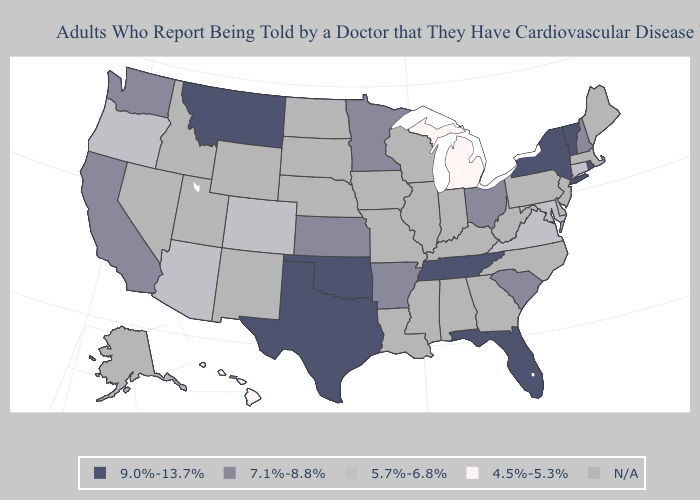What is the lowest value in the USA?
Concise answer only. 4.5%-5.3%. Name the states that have a value in the range 7.1%-8.8%?
Short answer required. Arkansas, California, Kansas, Minnesota, New Hampshire, Ohio, South Carolina, Washington. Does Ohio have the lowest value in the MidWest?
Be succinct. No. What is the value of Nebraska?
Answer briefly. N/A. Name the states that have a value in the range 9.0%-13.7%?
Give a very brief answer. Florida, Montana, New York, Oklahoma, Rhode Island, Tennessee, Texas, Vermont. What is the value of Indiana?
Give a very brief answer. N/A. Does the map have missing data?
Concise answer only. Yes. Name the states that have a value in the range 5.7%-6.8%?
Give a very brief answer. Arizona, Colorado, Connecticut, Maryland, Oregon, Virginia. What is the highest value in states that border Rhode Island?
Give a very brief answer. 5.7%-6.8%. Does the first symbol in the legend represent the smallest category?
Keep it brief. No. Name the states that have a value in the range 7.1%-8.8%?
Give a very brief answer. Arkansas, California, Kansas, Minnesota, New Hampshire, Ohio, South Carolina, Washington. Does the first symbol in the legend represent the smallest category?
Give a very brief answer. No. 